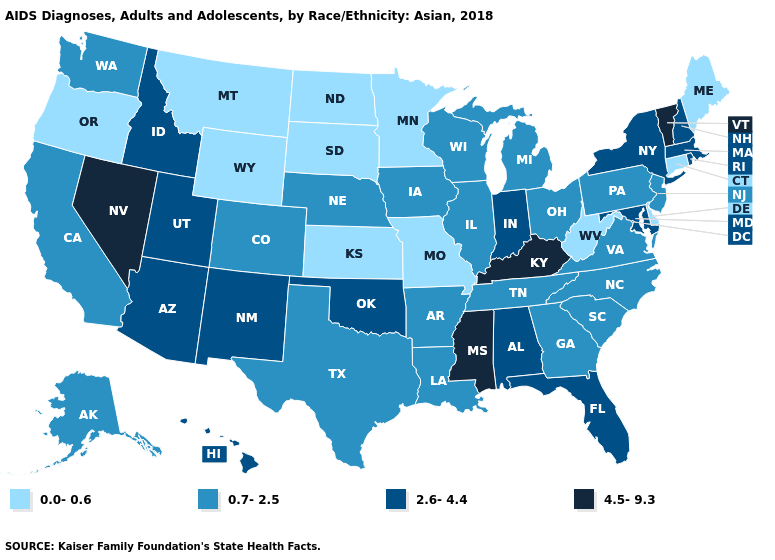Name the states that have a value in the range 0.7-2.5?
Quick response, please. Alaska, Arkansas, California, Colorado, Georgia, Illinois, Iowa, Louisiana, Michigan, Nebraska, New Jersey, North Carolina, Ohio, Pennsylvania, South Carolina, Tennessee, Texas, Virginia, Washington, Wisconsin. What is the highest value in the USA?
Concise answer only. 4.5-9.3. Name the states that have a value in the range 0.0-0.6?
Short answer required. Connecticut, Delaware, Kansas, Maine, Minnesota, Missouri, Montana, North Dakota, Oregon, South Dakota, West Virginia, Wyoming. Name the states that have a value in the range 2.6-4.4?
Give a very brief answer. Alabama, Arizona, Florida, Hawaii, Idaho, Indiana, Maryland, Massachusetts, New Hampshire, New Mexico, New York, Oklahoma, Rhode Island, Utah. Is the legend a continuous bar?
Give a very brief answer. No. Does the map have missing data?
Keep it brief. No. Does Nevada have the highest value in the West?
Keep it brief. Yes. What is the value of Illinois?
Keep it brief. 0.7-2.5. How many symbols are there in the legend?
Keep it brief. 4. Does Iowa have the same value as Delaware?
Write a very short answer. No. Name the states that have a value in the range 4.5-9.3?
Answer briefly. Kentucky, Mississippi, Nevada, Vermont. Does Michigan have the lowest value in the USA?
Keep it brief. No. Which states have the lowest value in the West?
Answer briefly. Montana, Oregon, Wyoming. What is the highest value in states that border Oklahoma?
Concise answer only. 2.6-4.4. Name the states that have a value in the range 2.6-4.4?
Quick response, please. Alabama, Arizona, Florida, Hawaii, Idaho, Indiana, Maryland, Massachusetts, New Hampshire, New Mexico, New York, Oklahoma, Rhode Island, Utah. 